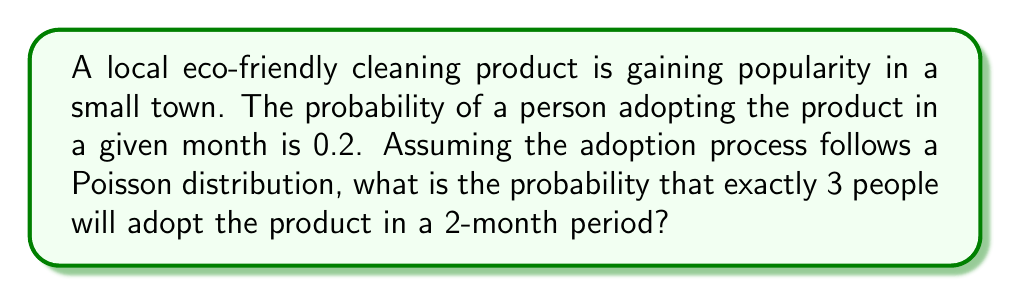Help me with this question. Let's approach this step-by-step:

1) First, we need to determine the rate parameter λ for the Poisson distribution. 
   - The probability of adoption per month is 0.2
   - We're looking at a 2-month period
   - The expected number of adoptions in 2 months is: λ = 0.2 * 2 * N, where N is the population

2) For simplicity, let's assume the town has 100 people. So:
   λ = 0.2 * 2 * 100 = 40

3) The Poisson probability mass function is:

   $$P(X = k) = \frac{e^{-λ} λ^k}{k!}$$

   Where:
   - e is Euler's number (approximately 2.71828)
   - λ is the rate parameter
   - k is the number of events (in this case, 3 adoptions)

4) Plugging in our values:

   $$P(X = 3) = \frac{e^{-40} 40^3}{3!}$$

5) Calculating this:
   
   $$P(X = 3) = \frac{2.71828^{-40} * 40^3}{3 * 2 * 1} \approx 1.91 * 10^{-15}$$

6) This extremely small probability makes sense, as we would expect many more than 3 adoptions given the parameters.
Answer: $1.91 * 10^{-15}$ 